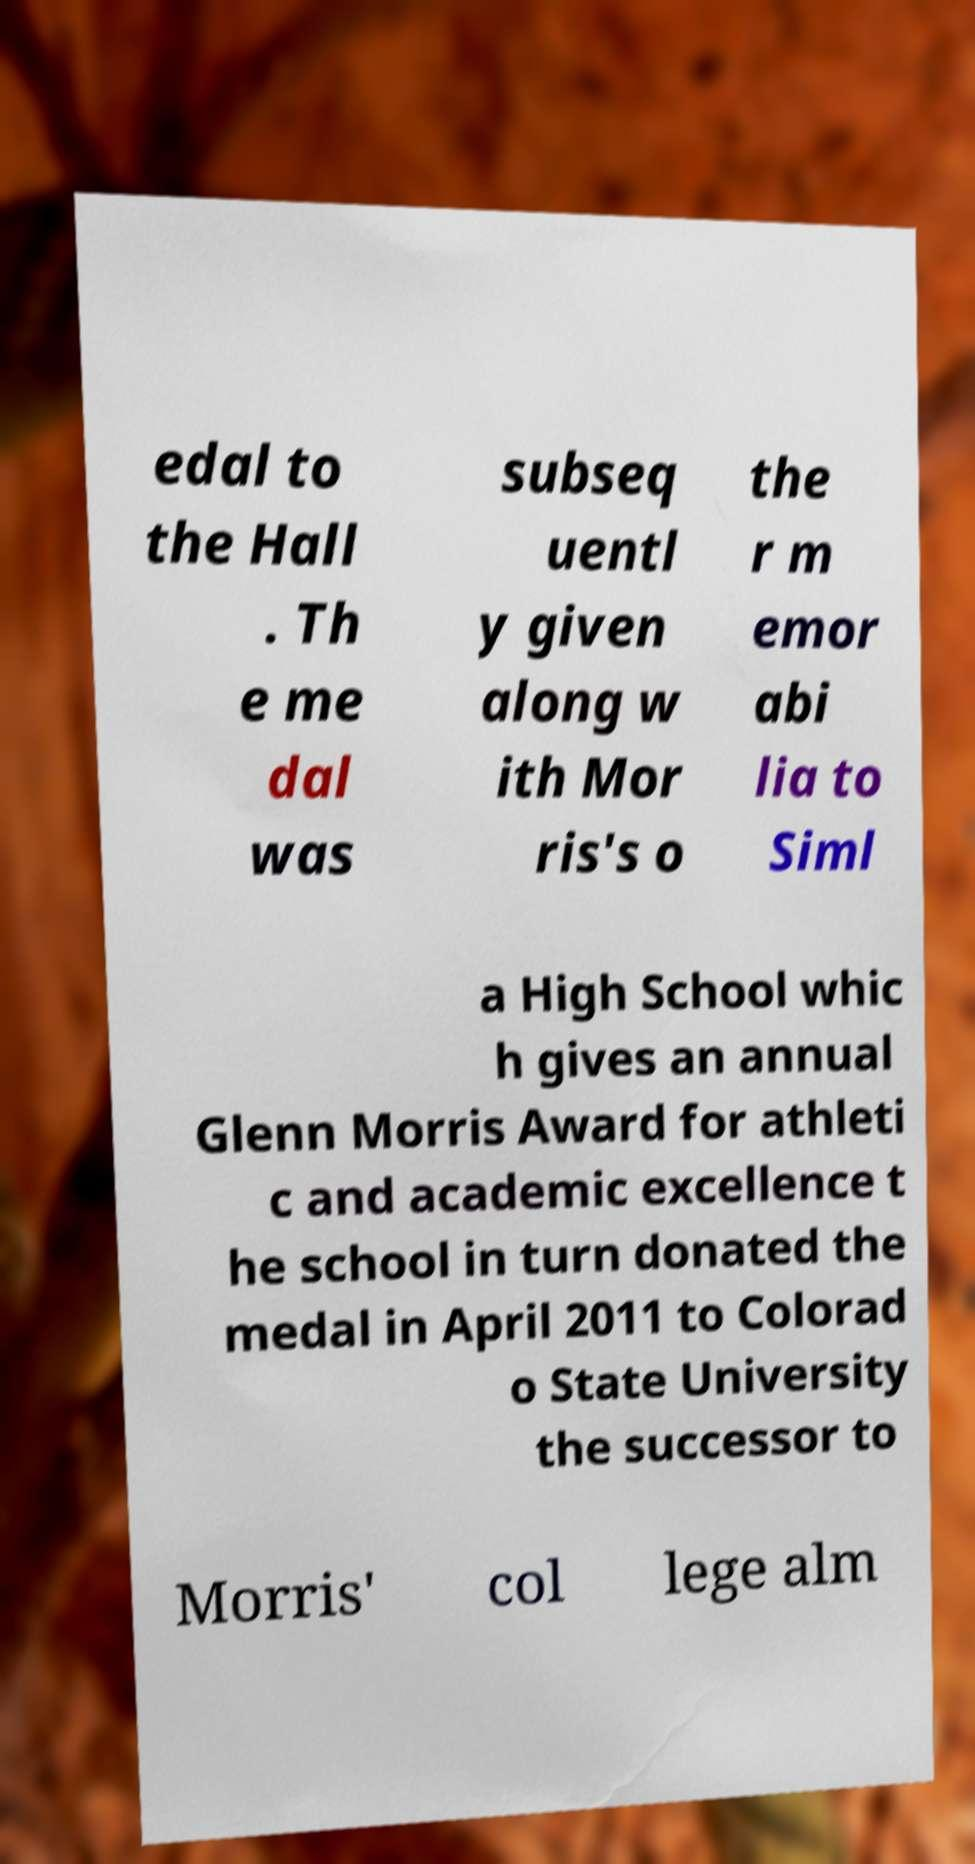Could you assist in decoding the text presented in this image and type it out clearly? edal to the Hall . Th e me dal was subseq uentl y given along w ith Mor ris's o the r m emor abi lia to Siml a High School whic h gives an annual Glenn Morris Award for athleti c and academic excellence t he school in turn donated the medal in April 2011 to Colorad o State University the successor to Morris' col lege alm 